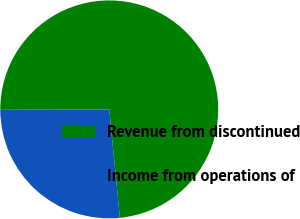Convert chart. <chart><loc_0><loc_0><loc_500><loc_500><pie_chart><fcel>Revenue from discontinued<fcel>Income from operations of<nl><fcel>73.51%<fcel>26.49%<nl></chart> 